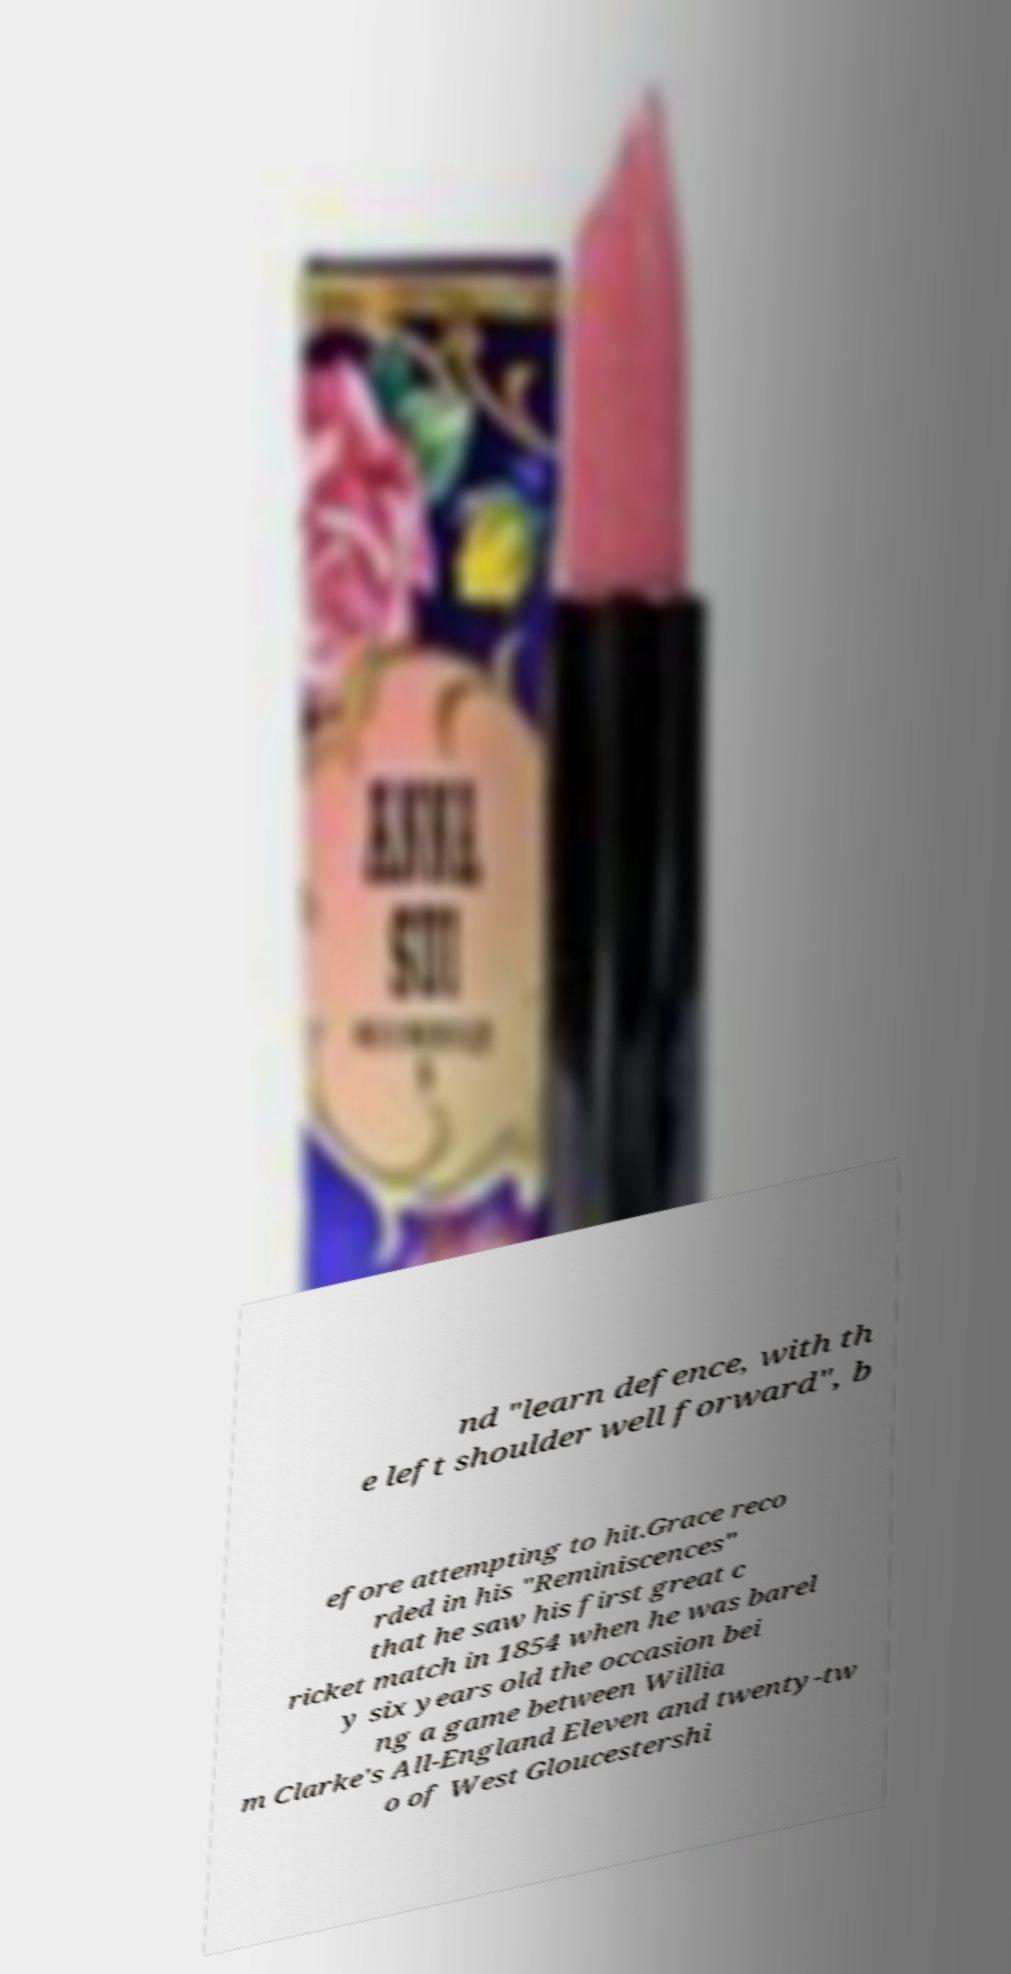For documentation purposes, I need the text within this image transcribed. Could you provide that? nd "learn defence, with th e left shoulder well forward", b efore attempting to hit.Grace reco rded in his "Reminiscences" that he saw his first great c ricket match in 1854 when he was barel y six years old the occasion bei ng a game between Willia m Clarke's All-England Eleven and twenty-tw o of West Gloucestershi 